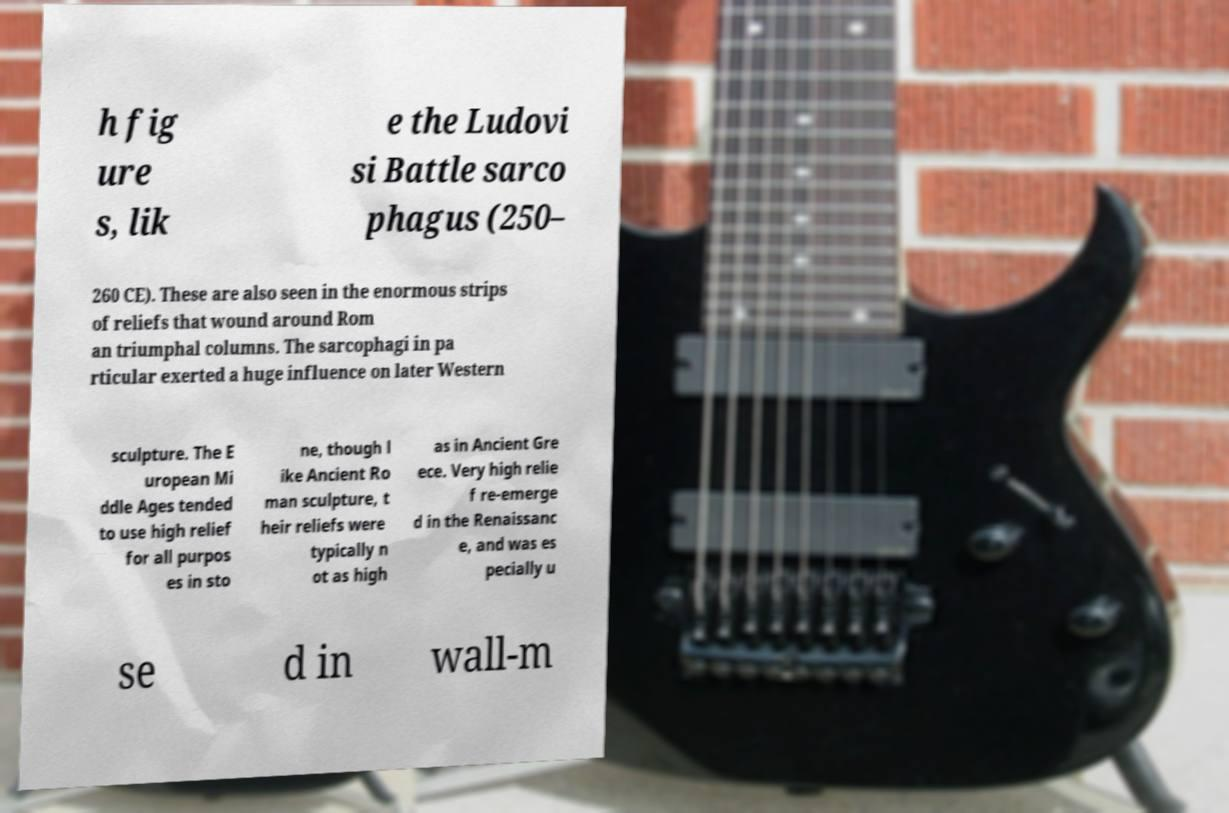Could you assist in decoding the text presented in this image and type it out clearly? h fig ure s, lik e the Ludovi si Battle sarco phagus (250– 260 CE). These are also seen in the enormous strips of reliefs that wound around Rom an triumphal columns. The sarcophagi in pa rticular exerted a huge influence on later Western sculpture. The E uropean Mi ddle Ages tended to use high relief for all purpos es in sto ne, though l ike Ancient Ro man sculpture, t heir reliefs were typically n ot as high as in Ancient Gre ece. Very high relie f re-emerge d in the Renaissanc e, and was es pecially u se d in wall-m 